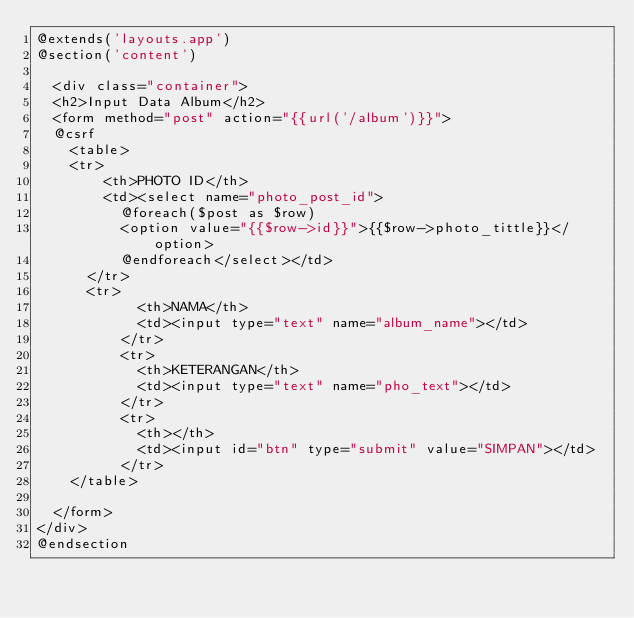Convert code to text. <code><loc_0><loc_0><loc_500><loc_500><_PHP_>@extends('layouts.app')
@section('content')

	<div class="container">
	<h2>Input Data Album</h2>
	<form method="post" action="{{url('/album')}}">
	@csrf
		<table>
		<tr>
				<th>PHOTO ID</th>
				<td><select name="photo_post_id">
					@foreach($post as $row)
					<option value="{{$row->id}}">{{$row->photo_tittle}}</option>
					@endforeach</select></td>
			</tr>
			<tr>
						<th>NAMA</th>
						<td><input type="text" name="album_name"></td>
					</tr>
					<tr>
						<th>KETERANGAN</th>
						<td><input type="text" name="pho_text"></td>
					</tr>
					<tr>
						<th></th>
						<td><input id="btn" type="submit" value="SIMPAN"></td>
					</tr>
		</table>
		
	</form>
</div>
@endsection</code> 